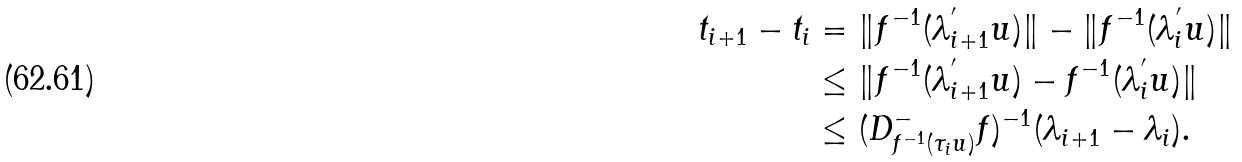<formula> <loc_0><loc_0><loc_500><loc_500>t _ { i + 1 } - t _ { i } & = \| f ^ { - 1 } ( \lambda _ { i + 1 } ^ { ^ { \prime } } u ) \| - \| f ^ { - 1 } ( \lambda _ { i } ^ { ^ { \prime } } u ) \| \\ & \leq \| f ^ { - 1 } ( \lambda _ { i + 1 } ^ { ^ { \prime } } u ) - f ^ { - 1 } ( \lambda _ { i } ^ { ^ { \prime } } u ) \| \\ & \leq ( D _ { f ^ { - 1 } ( \tau _ { i } u ) } ^ { - } f ) ^ { - 1 } ( \lambda _ { i + 1 } - \lambda _ { i } ) .</formula> 